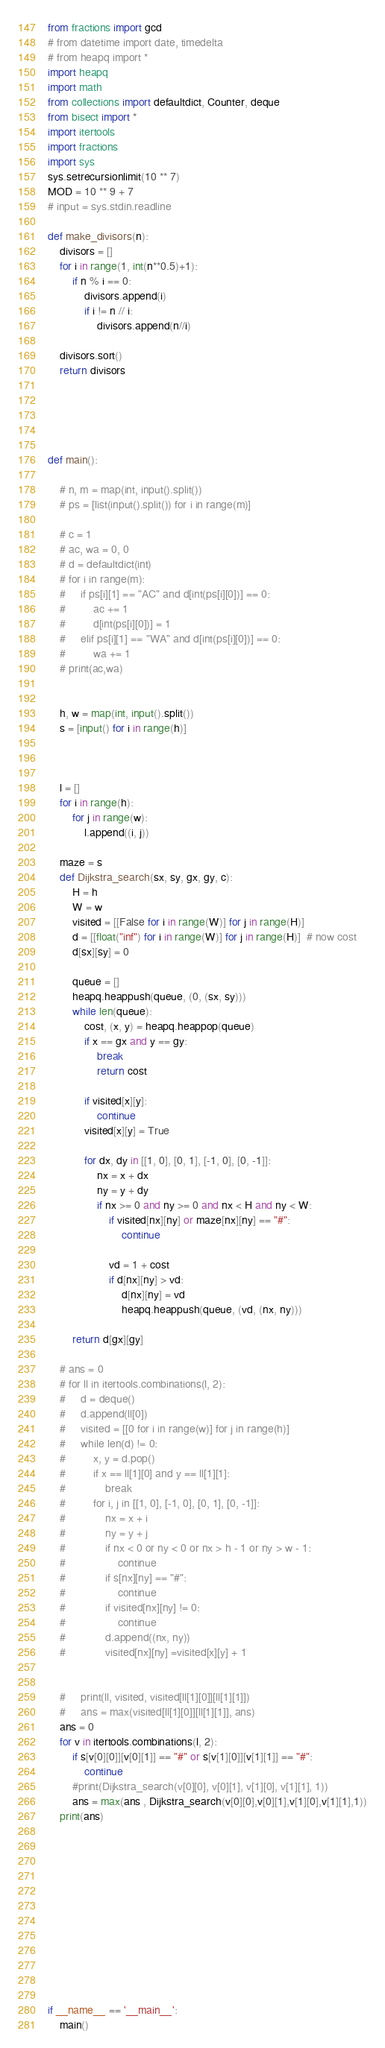Convert code to text. <code><loc_0><loc_0><loc_500><loc_500><_Python_>from fractions import gcd
# from datetime import date, timedelta
# from heapq import *
import heapq
import math
from collections import defaultdict, Counter, deque
from bisect import *
import itertools
import fractions
import sys
sys.setrecursionlimit(10 ** 7)
MOD = 10 ** 9 + 7
# input = sys.stdin.readline

def make_divisors(n):
    divisors = []
    for i in range(1, int(n**0.5)+1):
        if n % i == 0:
            divisors.append(i)
            if i != n // i:
                divisors.append(n//i)

    divisors.sort()
    return divisors





def main():
    
    # n, m = map(int, input().split())
    # ps = [list(input().split()) for i in range(m)]

    # c = 1
    # ac, wa = 0, 0
    # d = defaultdict(int)
    # for i in range(m):
    #     if ps[i][1] == "AC" and d[int(ps[i][0])] == 0:
    #         ac += 1
    #         d[int(ps[i][0])] = 1
    #     elif ps[i][1] == "WA" and d[int(ps[i][0])] == 0:
    #         wa += 1
    # print(ac,wa)
            
    
    h, w = map(int, input().split())
    s = [input() for i in range(h)]



    l = []
    for i in range(h):
        for j in range(w):
            l.append((i, j))

    maze = s
    def Dijkstra_search(sx, sy, gx, gy, c):
        H = h
        W = w
        visited = [[False for i in range(W)] for j in range(H)]
        d = [[float("inf") for i in range(W)] for j in range(H)]  # now cost
        d[sx][sy] = 0

        queue = []
        heapq.heappush(queue, (0, (sx, sy)))
        while len(queue):
            cost, (x, y) = heapq.heappop(queue)
            if x == gx and y == gy:
                break
                return cost

            if visited[x][y]:
                continue
            visited[x][y] = True

            for dx, dy in [[1, 0], [0, 1], [-1, 0], [0, -1]]:
                nx = x + dx
                ny = y + dy
                if nx >= 0 and ny >= 0 and nx < H and ny < W:
                    if visited[nx][ny] or maze[nx][ny] == "#":
                        continue

                    vd = 1 + cost
                    if d[nx][ny] > vd:
                        d[nx][ny] = vd
                        heapq.heappush(queue, (vd, (nx, ny)))

        return d[gx][gy]
    
    # ans = 0
    # for ll in itertools.combinations(l, 2):
    #     d = deque()
    #     d.append(ll[0])
    #     visited = [[0 for i in range(w)] for j in range(h)]
    #     while len(d) != 0:
    #         x, y = d.pop()
    #         if x == ll[1][0] and y == ll[1][1]:
    #             break
    #         for i, j in [[1, 0], [-1, 0], [0, 1], [0, -1]]:
    #             nx = x + i
    #             ny = y + j
    #             if nx < 0 or ny < 0 or nx > h - 1 or ny > w - 1:
    #                 continue
    #             if s[nx][ny] == "#":
    #                 continue
    #             if visited[nx][ny] != 0:
    #                 continue
    #             d.append((nx, ny))
    #             visited[nx][ny] =visited[x][y] + 1
        

    #     print(ll, visited, visited[ll[1][0]][ll[1][1]])
    #     ans = max(visited[ll[1][0]][ll[1][1]], ans)
    ans = 0
    for v in itertools.combinations(l, 2):
        if s[v[0][0]][v[0][1]] == "#" or s[v[1][0]][v[1][1]] == "#":
            continue
        #print(Dijkstra_search(v[0][0], v[0][1], v[1][0], v[1][1], 1))
        ans = max(ans , Dijkstra_search(v[0][0],v[0][1],v[1][0],v[1][1],1))
    print(ans)
                


                
        




    


if __name__ == '__main__':
    main()
</code> 